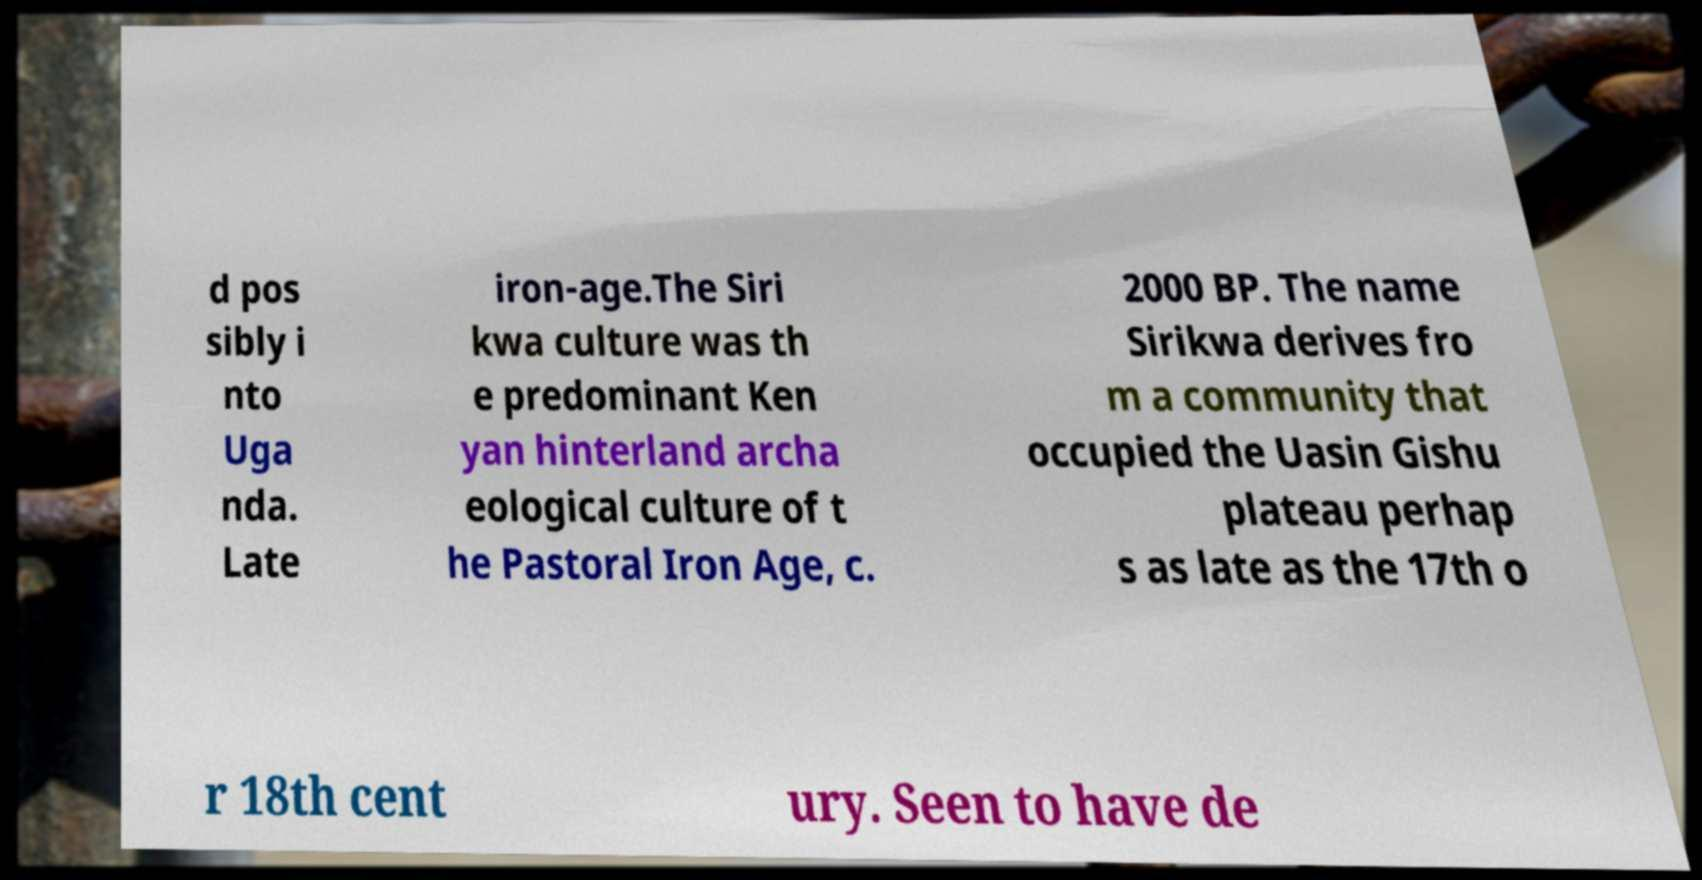Could you assist in decoding the text presented in this image and type it out clearly? d pos sibly i nto Uga nda. Late iron-age.The Siri kwa culture was th e predominant Ken yan hinterland archa eological culture of t he Pastoral Iron Age, c. 2000 BP. The name Sirikwa derives fro m a community that occupied the Uasin Gishu plateau perhap s as late as the 17th o r 18th cent ury. Seen to have de 